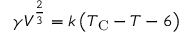Convert formula to latex. <formula><loc_0><loc_0><loc_500><loc_500>\gamma V ^ { \frac { 2 } { 3 } } = k \left ( T _ { C } - T - 6 \right )</formula> 